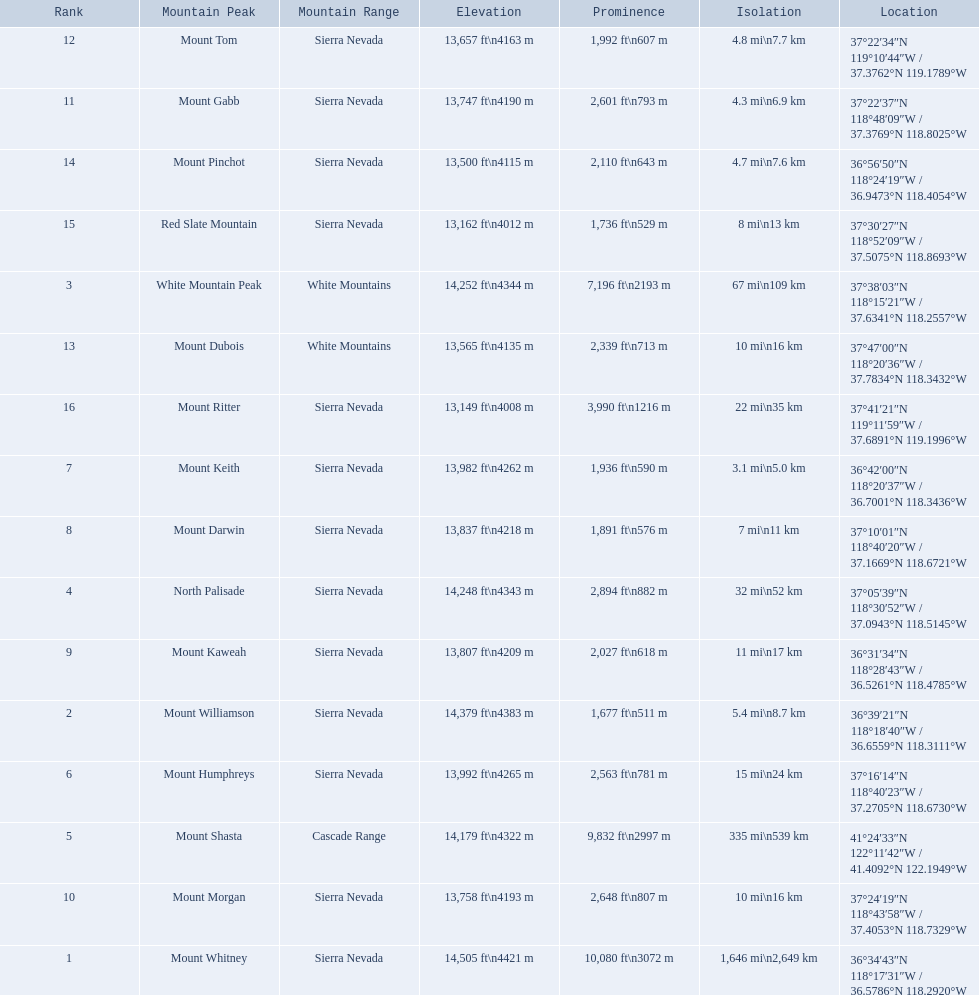Which mountain peaks are lower than 14,000 ft? Mount Humphreys, Mount Keith, Mount Darwin, Mount Kaweah, Mount Morgan, Mount Gabb, Mount Tom, Mount Dubois, Mount Pinchot, Red Slate Mountain, Mount Ritter. Are any of them below 13,500? if so, which ones? Red Slate Mountain, Mount Ritter. What's the lowest peak? 13,149 ft\n4008 m. Which one is that? Mount Ritter. What are the peaks in california? Mount Whitney, Mount Williamson, White Mountain Peak, North Palisade, Mount Shasta, Mount Humphreys, Mount Keith, Mount Darwin, Mount Kaweah, Mount Morgan, Mount Gabb, Mount Tom, Mount Dubois, Mount Pinchot, Red Slate Mountain, Mount Ritter. What are the peaks in sierra nevada, california? Mount Whitney, Mount Williamson, North Palisade, Mount Humphreys, Mount Keith, Mount Darwin, Mount Kaweah, Mount Morgan, Mount Gabb, Mount Tom, Mount Pinchot, Red Slate Mountain, Mount Ritter. What are the heights of the peaks in sierra nevada? 14,505 ft\n4421 m, 14,379 ft\n4383 m, 14,248 ft\n4343 m, 13,992 ft\n4265 m, 13,982 ft\n4262 m, 13,837 ft\n4218 m, 13,807 ft\n4209 m, 13,758 ft\n4193 m, 13,747 ft\n4190 m, 13,657 ft\n4163 m, 13,500 ft\n4115 m, 13,162 ft\n4012 m, 13,149 ft\n4008 m. Which is the highest? Mount Whitney. Can you give me this table as a dict? {'header': ['Rank', 'Mountain Peak', 'Mountain Range', 'Elevation', 'Prominence', 'Isolation', 'Location'], 'rows': [['12', 'Mount Tom', 'Sierra Nevada', '13,657\xa0ft\\n4163\xa0m', '1,992\xa0ft\\n607\xa0m', '4.8\xa0mi\\n7.7\xa0km', '37°22′34″N 119°10′44″W\ufeff / \ufeff37.3762°N 119.1789°W'], ['11', 'Mount Gabb', 'Sierra Nevada', '13,747\xa0ft\\n4190\xa0m', '2,601\xa0ft\\n793\xa0m', '4.3\xa0mi\\n6.9\xa0km', '37°22′37″N 118°48′09″W\ufeff / \ufeff37.3769°N 118.8025°W'], ['14', 'Mount Pinchot', 'Sierra Nevada', '13,500\xa0ft\\n4115\xa0m', '2,110\xa0ft\\n643\xa0m', '4.7\xa0mi\\n7.6\xa0km', '36°56′50″N 118°24′19″W\ufeff / \ufeff36.9473°N 118.4054°W'], ['15', 'Red Slate Mountain', 'Sierra Nevada', '13,162\xa0ft\\n4012\xa0m', '1,736\xa0ft\\n529\xa0m', '8\xa0mi\\n13\xa0km', '37°30′27″N 118°52′09″W\ufeff / \ufeff37.5075°N 118.8693°W'], ['3', 'White Mountain Peak', 'White Mountains', '14,252\xa0ft\\n4344\xa0m', '7,196\xa0ft\\n2193\xa0m', '67\xa0mi\\n109\xa0km', '37°38′03″N 118°15′21″W\ufeff / \ufeff37.6341°N 118.2557°W'], ['13', 'Mount Dubois', 'White Mountains', '13,565\xa0ft\\n4135\xa0m', '2,339\xa0ft\\n713\xa0m', '10\xa0mi\\n16\xa0km', '37°47′00″N 118°20′36″W\ufeff / \ufeff37.7834°N 118.3432°W'], ['16', 'Mount Ritter', 'Sierra Nevada', '13,149\xa0ft\\n4008\xa0m', '3,990\xa0ft\\n1216\xa0m', '22\xa0mi\\n35\xa0km', '37°41′21″N 119°11′59″W\ufeff / \ufeff37.6891°N 119.1996°W'], ['7', 'Mount Keith', 'Sierra Nevada', '13,982\xa0ft\\n4262\xa0m', '1,936\xa0ft\\n590\xa0m', '3.1\xa0mi\\n5.0\xa0km', '36°42′00″N 118°20′37″W\ufeff / \ufeff36.7001°N 118.3436°W'], ['8', 'Mount Darwin', 'Sierra Nevada', '13,837\xa0ft\\n4218\xa0m', '1,891\xa0ft\\n576\xa0m', '7\xa0mi\\n11\xa0km', '37°10′01″N 118°40′20″W\ufeff / \ufeff37.1669°N 118.6721°W'], ['4', 'North Palisade', 'Sierra Nevada', '14,248\xa0ft\\n4343\xa0m', '2,894\xa0ft\\n882\xa0m', '32\xa0mi\\n52\xa0km', '37°05′39″N 118°30′52″W\ufeff / \ufeff37.0943°N 118.5145°W'], ['9', 'Mount Kaweah', 'Sierra Nevada', '13,807\xa0ft\\n4209\xa0m', '2,027\xa0ft\\n618\xa0m', '11\xa0mi\\n17\xa0km', '36°31′34″N 118°28′43″W\ufeff / \ufeff36.5261°N 118.4785°W'], ['2', 'Mount Williamson', 'Sierra Nevada', '14,379\xa0ft\\n4383\xa0m', '1,677\xa0ft\\n511\xa0m', '5.4\xa0mi\\n8.7\xa0km', '36°39′21″N 118°18′40″W\ufeff / \ufeff36.6559°N 118.3111°W'], ['6', 'Mount Humphreys', 'Sierra Nevada', '13,992\xa0ft\\n4265\xa0m', '2,563\xa0ft\\n781\xa0m', '15\xa0mi\\n24\xa0km', '37°16′14″N 118°40′23″W\ufeff / \ufeff37.2705°N 118.6730°W'], ['5', 'Mount Shasta', 'Cascade Range', '14,179\xa0ft\\n4322\xa0m', '9,832\xa0ft\\n2997\xa0m', '335\xa0mi\\n539\xa0km', '41°24′33″N 122°11′42″W\ufeff / \ufeff41.4092°N 122.1949°W'], ['10', 'Mount Morgan', 'Sierra Nevada', '13,758\xa0ft\\n4193\xa0m', '2,648\xa0ft\\n807\xa0m', '10\xa0mi\\n16\xa0km', '37°24′19″N 118°43′58″W\ufeff / \ufeff37.4053°N 118.7329°W'], ['1', 'Mount Whitney', 'Sierra Nevada', '14,505\xa0ft\\n4421\xa0m', '10,080\xa0ft\\n3072\xa0m', '1,646\xa0mi\\n2,649\xa0km', '36°34′43″N 118°17′31″W\ufeff / \ufeff36.5786°N 118.2920°W']]} 